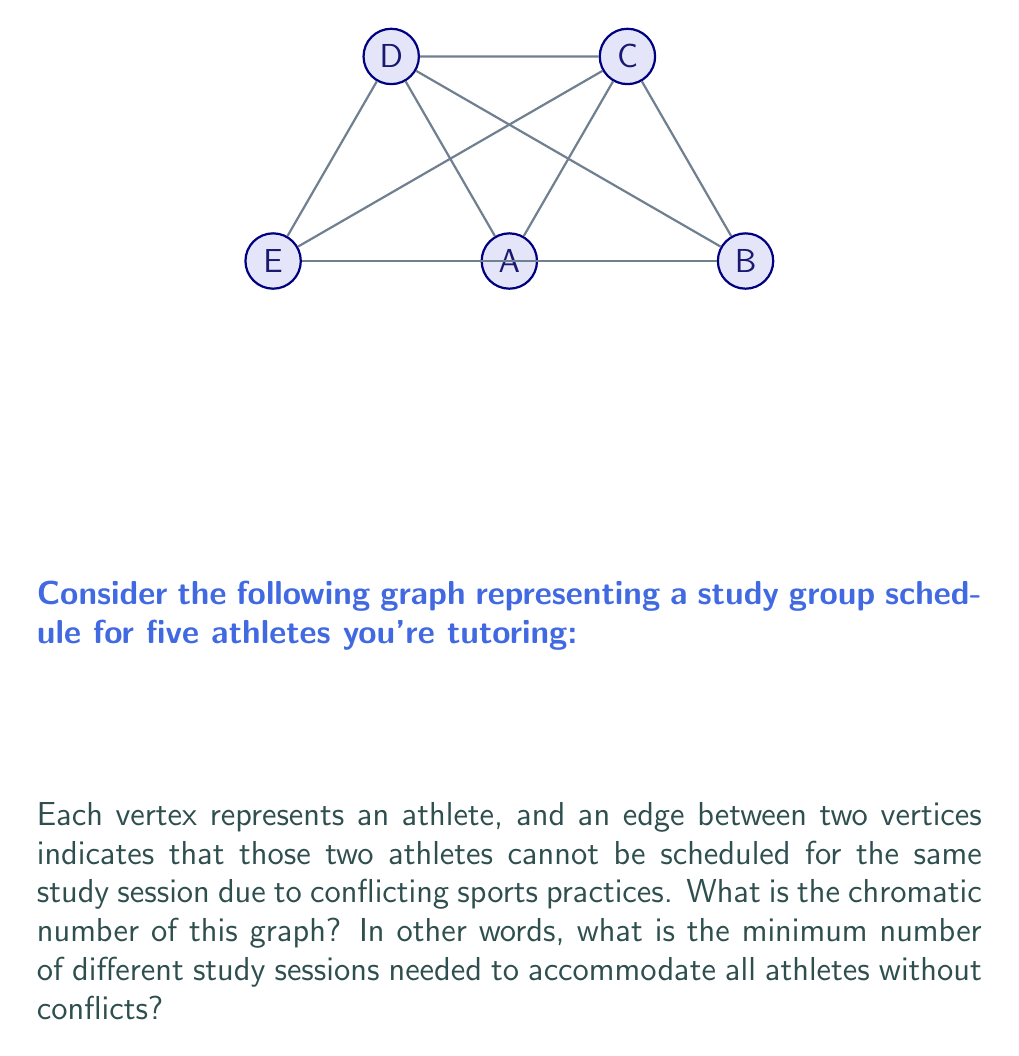Show me your answer to this math problem. Let's approach this step-by-step using graph coloring techniques:

1) First, we need to understand what the chromatic number represents. The chromatic number is the minimum number of colors needed to color the vertices of a graph such that no two adjacent vertices share the same color.

2) In this context, each color represents a different study session time slot.

3) Let's start coloring the graph:
   - We can start with vertex A. Let's color it red.
   - B is connected to A, so it needs a different color. Let's use blue.
   - C is connected to both A and B, so it needs a third color. Let's use green.
   - D is connected to A, B, and C, so it needs a fourth color. Let's use yellow.
   - E is connected to B, C, and D, but not to A. We can color E red, the same as A.

4) Let's verify if we can reduce the number of colors:
   - We used 4 colors: red (A, E), blue (B), green (C), and yellow (D).
   - Each vertex is connected to all others except for the pair A and E.
   - There's no way to reduce the number of colors without creating a conflict.

5) Therefore, the minimum number of colors needed is 4.

6) In graph theory terms, this graph is known as a "4-chromatic graph" or more specifically, a "wheel graph with 5 vertices minus one spoke" (often denoted as $W_5 - e$).

Thus, the chromatic number of this graph is 4, meaning a minimum of 4 different study sessions are needed to accommodate all athletes without conflicts.
Answer: 4 